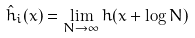Convert formula to latex. <formula><loc_0><loc_0><loc_500><loc_500>\hat { h } _ { i } ( x ) = \lim _ { N \to \infty } h ( x + \log N )</formula> 